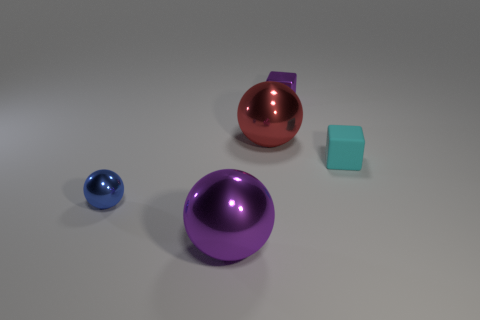Do the cyan rubber object and the blue shiny ball have the same size?
Your answer should be compact. Yes. Are there more large purple spheres than big shiny objects?
Provide a short and direct response. No. What number of other things are there of the same color as the metal block?
Keep it short and to the point. 1. What number of things are either small blue shiny balls or tiny brown matte balls?
Offer a very short reply. 1. Do the metallic thing left of the big purple thing and the large red thing have the same shape?
Your response must be concise. Yes. What color is the block in front of the small cube that is to the left of the tiny cyan rubber object?
Your answer should be compact. Cyan. Is the number of yellow shiny blocks less than the number of purple things?
Make the answer very short. Yes. Are there any tiny purple things made of the same material as the small cyan block?
Your response must be concise. No. There is a small cyan thing; does it have the same shape as the purple object in front of the blue metallic ball?
Provide a short and direct response. No. There is a small cyan thing; are there any small purple cubes to the left of it?
Provide a short and direct response. Yes. 